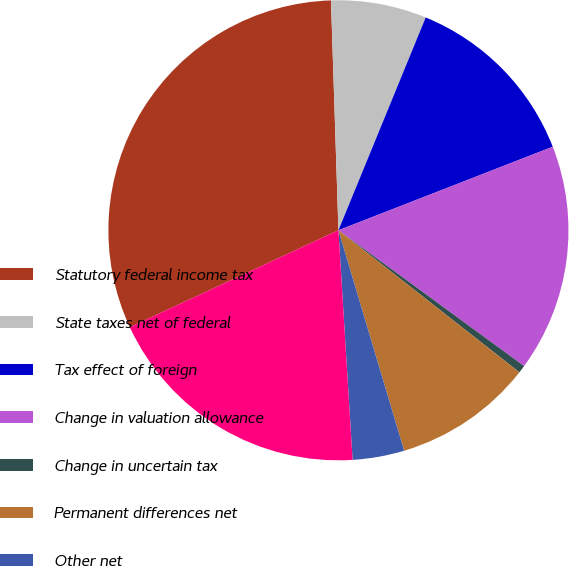Convert chart. <chart><loc_0><loc_0><loc_500><loc_500><pie_chart><fcel>Statutory federal income tax<fcel>State taxes net of federal<fcel>Tax effect of foreign<fcel>Change in valuation allowance<fcel>Change in uncertain tax<fcel>Permanent differences net<fcel>Other net<fcel>Effective tax rate<nl><fcel>31.41%<fcel>6.71%<fcel>12.89%<fcel>15.97%<fcel>0.54%<fcel>9.8%<fcel>3.63%<fcel>19.06%<nl></chart> 